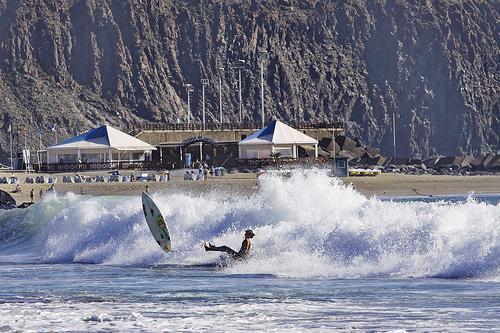How many people are in the water?
Give a very brief answer. 1. How many white buildings are in the background?
Give a very brief answer. 2. 